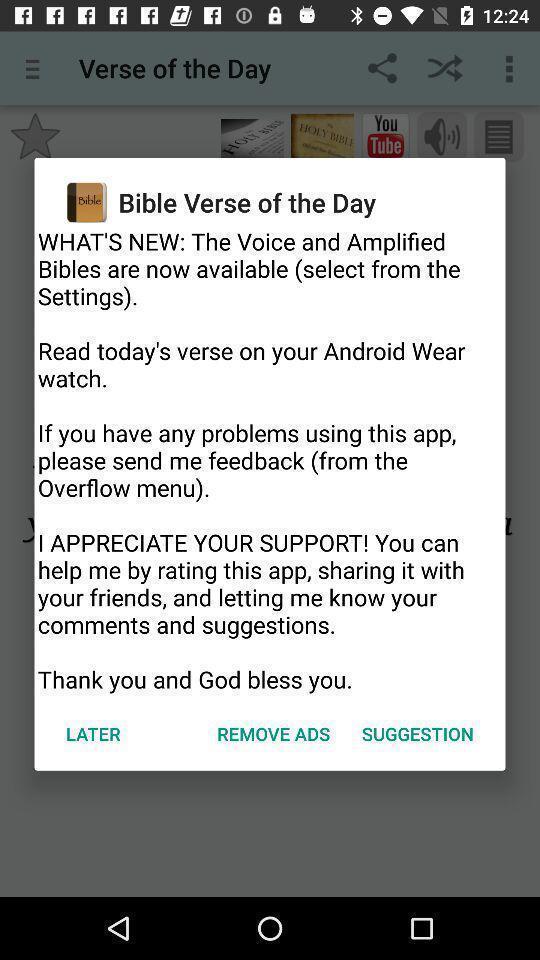Please provide a description for this image. Popup of a description of book in religious app. 